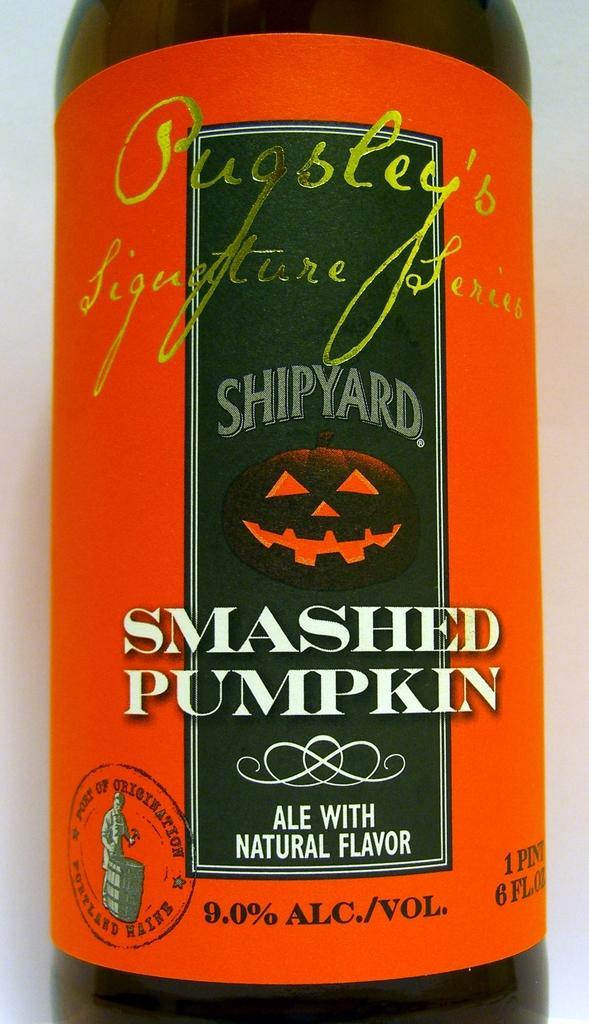How would you summarize this image in a sentence or two? In this image we can see a bottle with some text on it. 